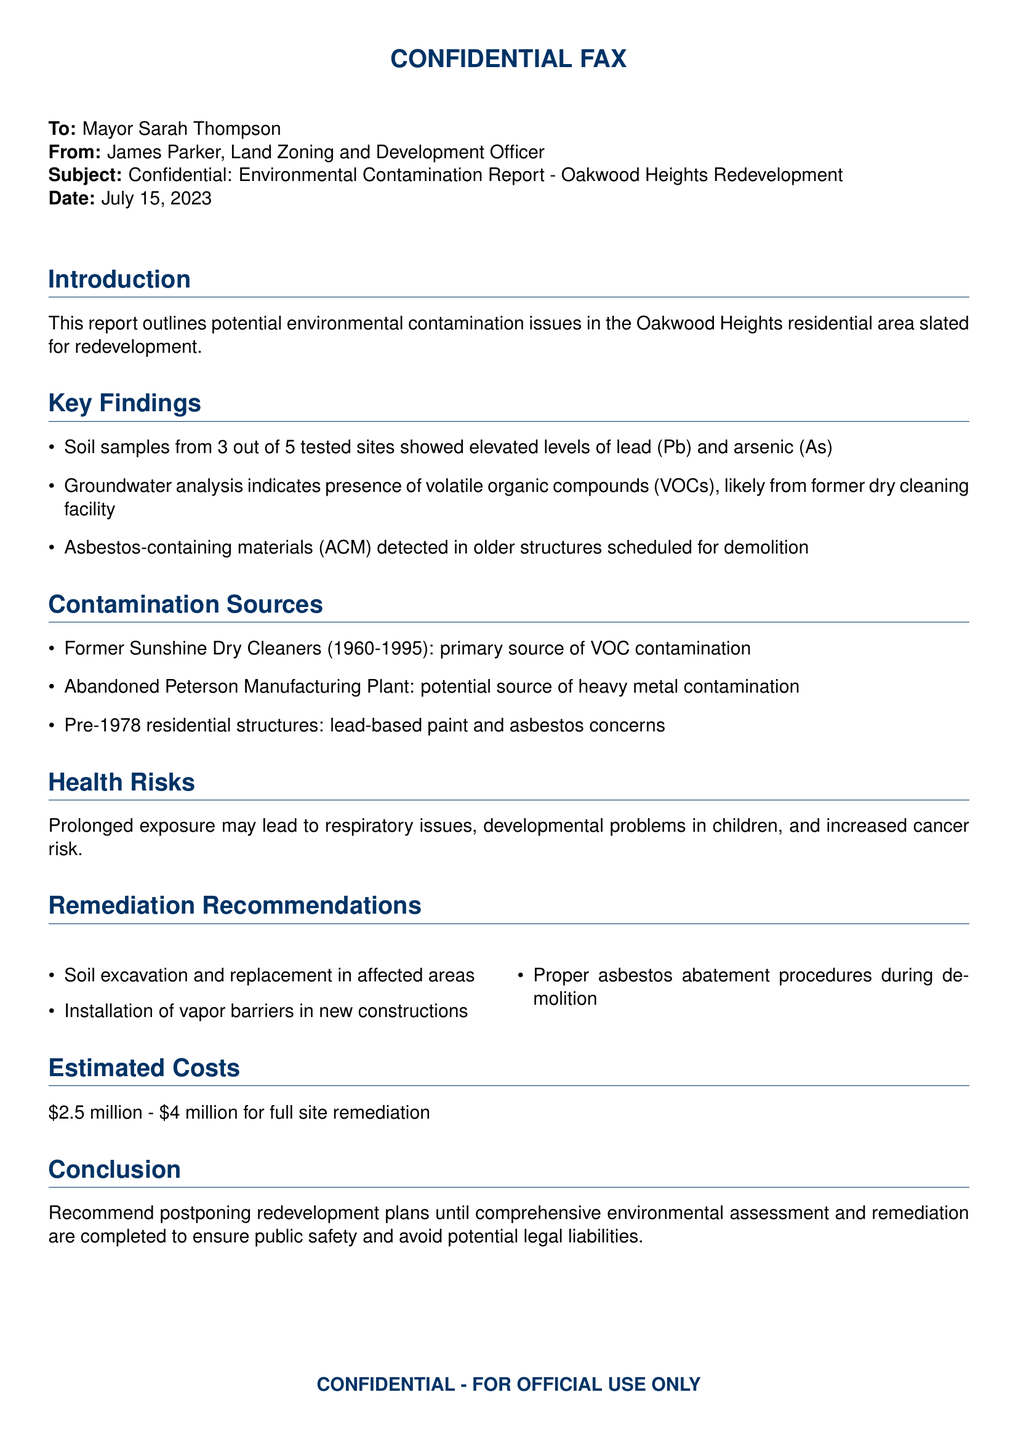What is the main subject of the fax? The fax primarily discusses environmental contamination issues in the Oakwood Heights area.
Answer: Environmental Contamination Report - Oakwood Heights Redevelopment How many tested sites showed elevated levels of lead and arsenic? The document indicates that 3 out of 5 tested sites had elevated levels of these contaminants.
Answer: 3 What is the presence of volatile organic compounds associated with? The presence of VOCs is linked to a former dry cleaning facility.
Answer: Former dry cleaning facility What are the potential health risks mentioned? The document states that prolonged exposure may lead to several health concerns including respiratory issues.
Answer: Respiratory issues, developmental problems, increased cancer risk What is the estimated cost range for full site remediation? The report provides a cost estimate for remediation efforts which ranges from $2.5 million to $4 million.
Answer: $2.5 million - $4 million What remediation procedure is recommended for asbestos? Proper asbestos abatement procedures are recommended during demolition.
Answer: Proper asbestos abatement procedures What was the operational period of the Sunshine Dry Cleaners? The Sunshine Dry Cleaners were operational from 1960 to 1995.
Answer: 1960-1995 What should be done before proceeding with redevelopment plans? The document recommends postponing redevelopment until environmental assessments and remediation are completed.
Answer: Postponing redevelopment plans 